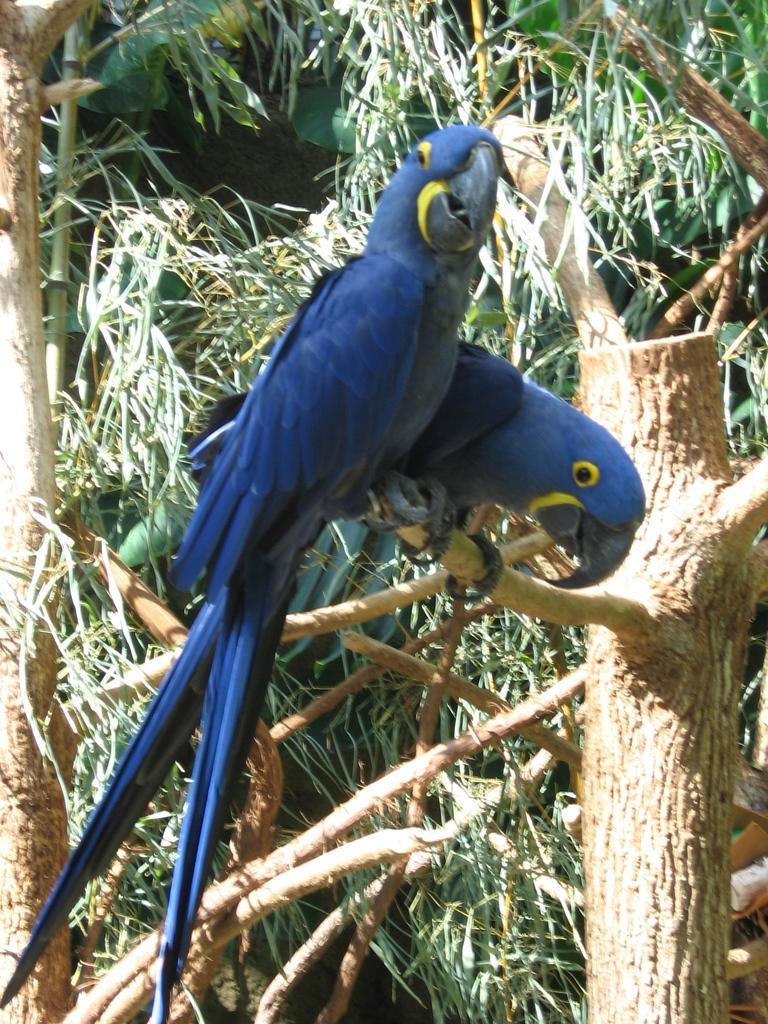How would you summarize this image in a sentence or two? In this picture I can see couple of birds on the tree branch and I can see trees in the background. 